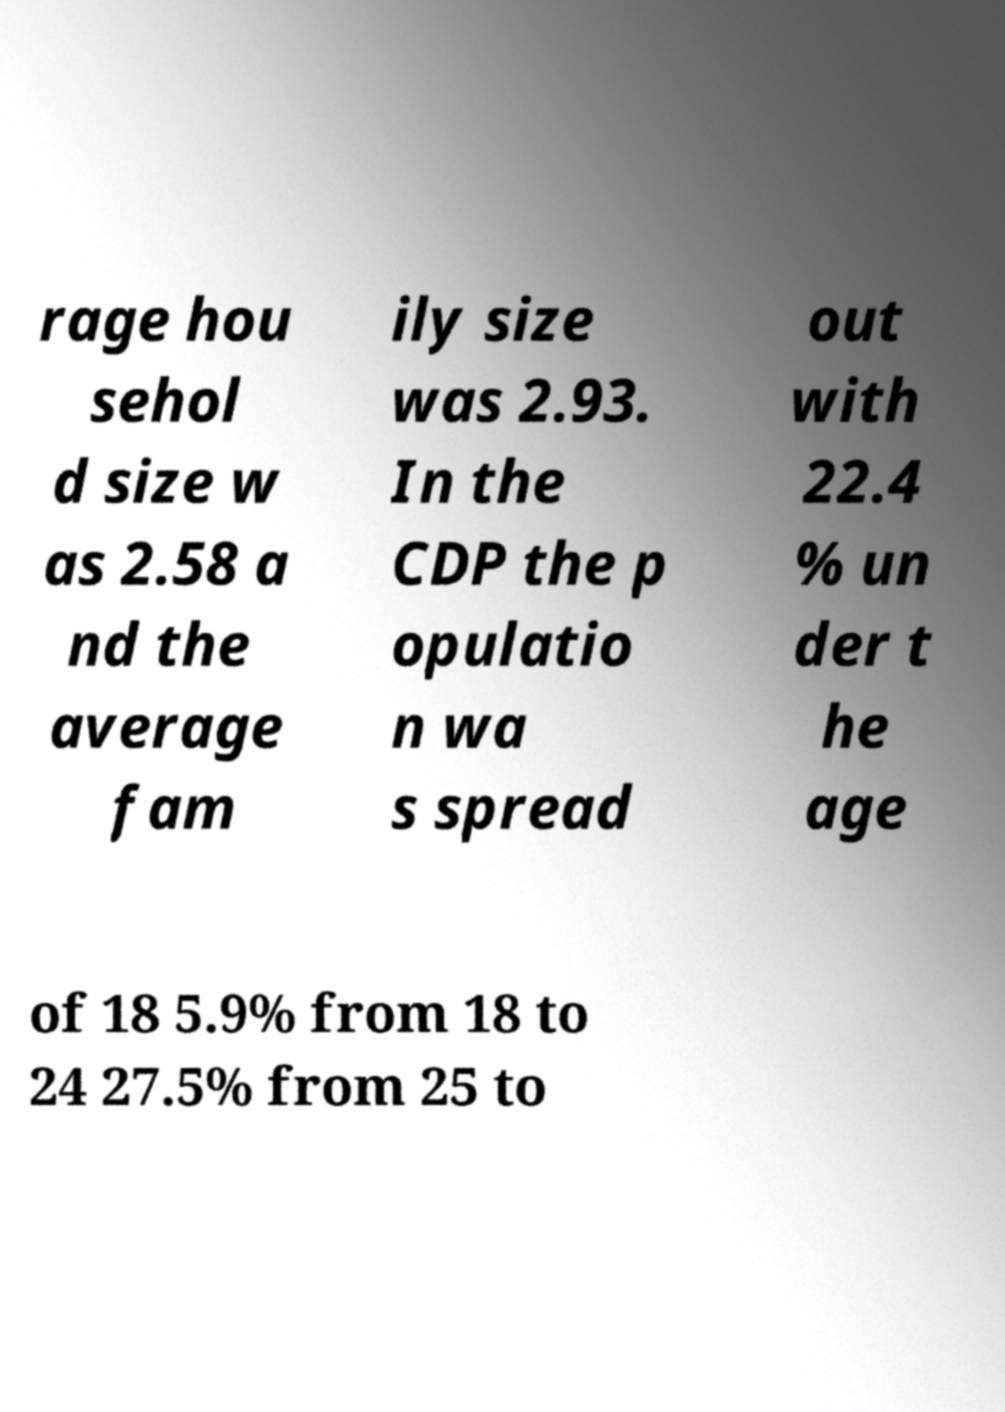Could you assist in decoding the text presented in this image and type it out clearly? rage hou sehol d size w as 2.58 a nd the average fam ily size was 2.93. In the CDP the p opulatio n wa s spread out with 22.4 % un der t he age of 18 5.9% from 18 to 24 27.5% from 25 to 